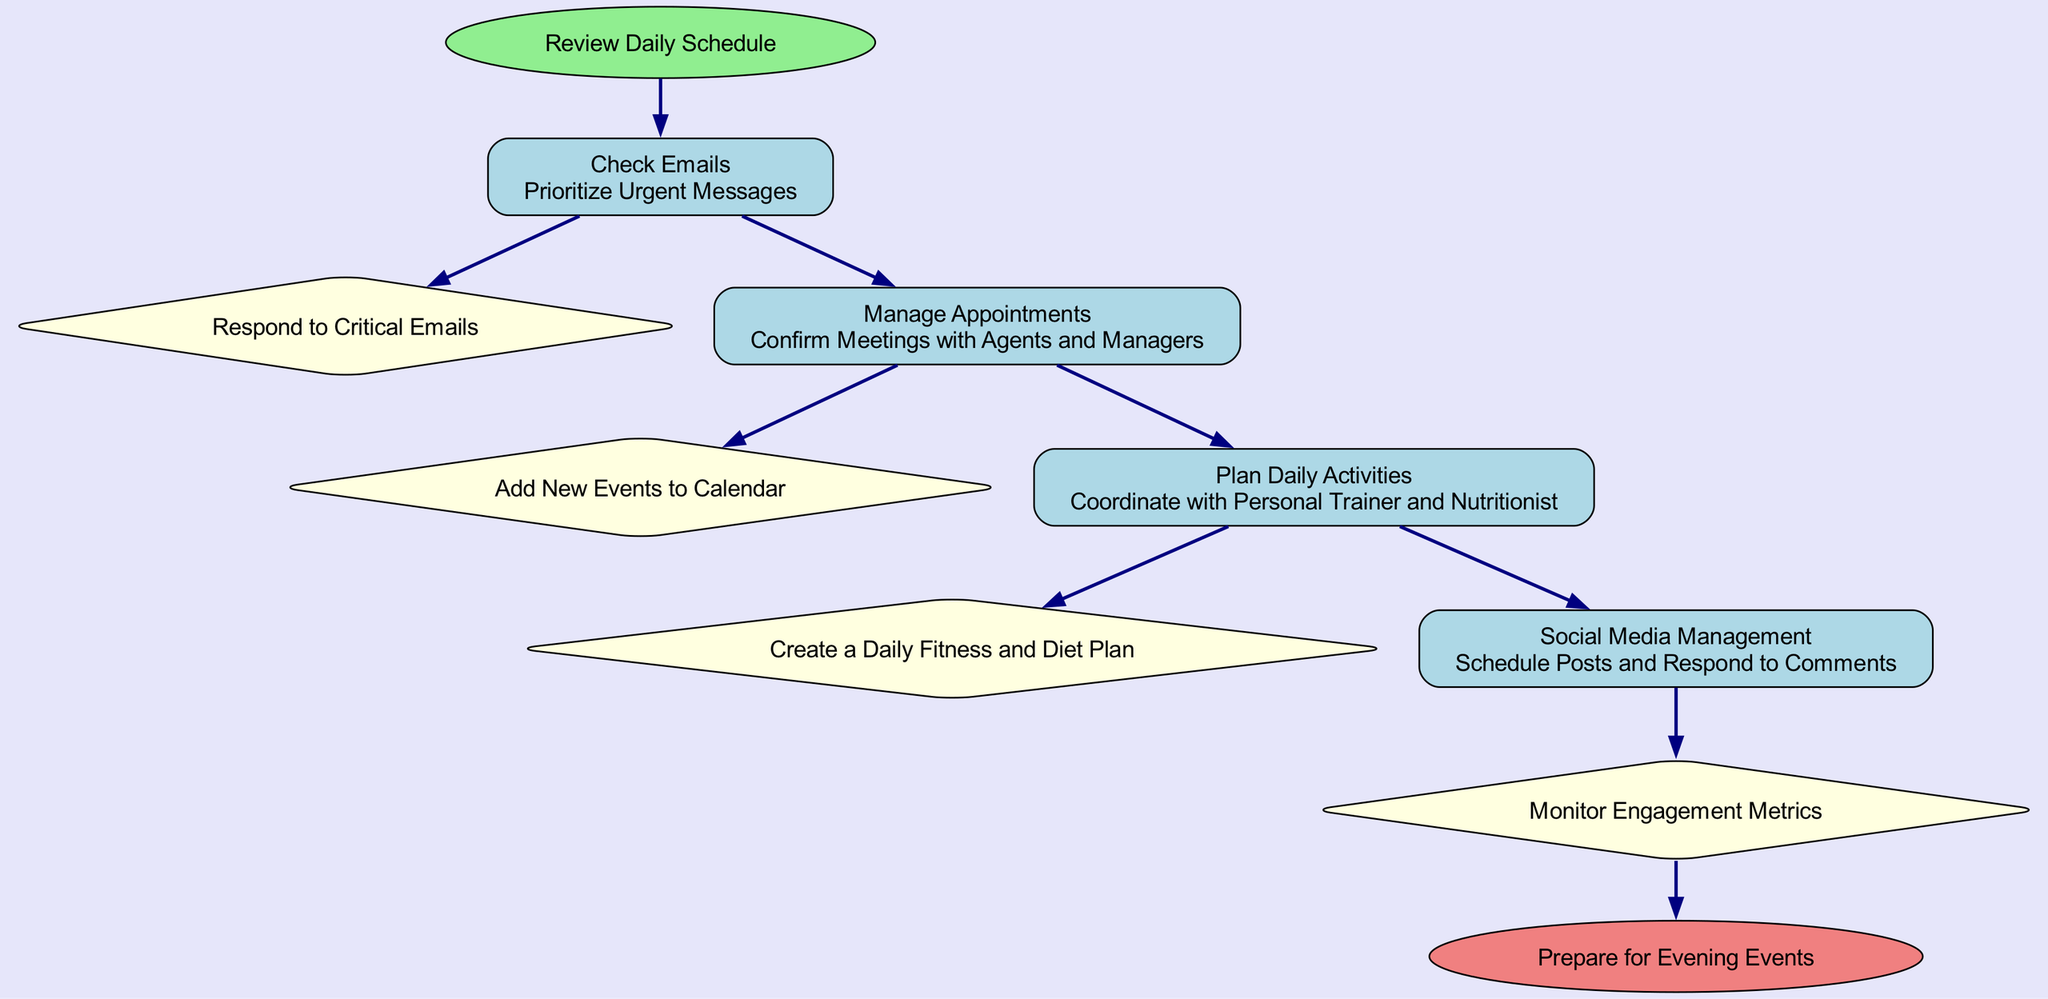What is the first task in the workflow? The workflow starts with the "Review Daily Schedule" action, leading directly to the first task which is "Check Emails."
Answer: Check Emails How many tasks are listed in the diagram? There are four tasks identified in the workflow: Check Emails, Manage Appointments, Plan Daily Activities, and Social Media Management.
Answer: 4 What action is taken after "Check Emails"? The action following "Check Emails" is to "Prioritize Urgent Messages," which is mentioned as part of the "Check Emails" task.
Answer: Prioritize Urgent Messages What is the last action before preparing for evening events? The last task to be completed before the workflow ends is "Monitor Engagement Metrics," concluding the action series.
Answer: Monitor Engagement Metrics What type of node is "Manage Appointments"? "Manage Appointments" is a task node, represented as a rectangle in the flow chart, indicating an action item in the workflow.
Answer: Task node Which task involves coordination with other professionals? "Plan Daily Activities" involves coordination specifically with the personal trainer and nutritionist, as stated in its action.
Answer: Plan Daily Activities What action follows the "Social Media Management"? The action that follows the "Social Media Management" task is to "Monitor Engagement Metrics," as indicated in the next step after handling social media.
Answer: Monitor Engagement Metrics How does "Check Emails" connect to "Respond to Critical Emails"? "Check Emails" leads to the action "Prioritize Urgent Messages," and upon completion, it connects to "Respond to Critical Emails" as the next step outlined in the workflow.
Answer: Respond to Critical Emails What color represents the end node in the diagram? The end node, labeled "Prepare for Evening Events," is represented in light coral color according to the diagram specifications.
Answer: Light coral 